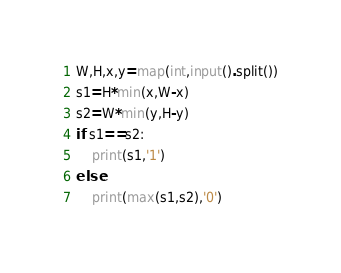<code> <loc_0><loc_0><loc_500><loc_500><_Python_>W,H,x,y=map(int,input().split())
s1=H*min(x,W-x)
s2=W*min(y,H-y)
if s1==s2:
    print(s1,'1')
else:
    print(max(s1,s2),'0')
</code> 